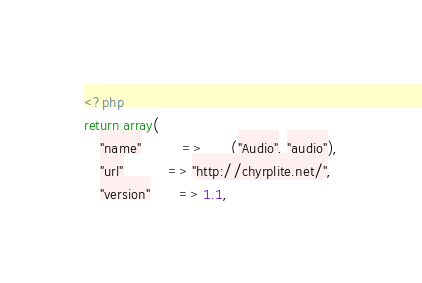<code> <loc_0><loc_0><loc_500><loc_500><_PHP_><?php
return array(
    "name"          => __("Audio", "audio"),
    "url"           => "http://chyrplite.net/",
    "version"       => 1.1,</code> 